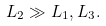<formula> <loc_0><loc_0><loc_500><loc_500>L _ { 2 } \gg L _ { 1 } , L _ { 3 } .</formula> 